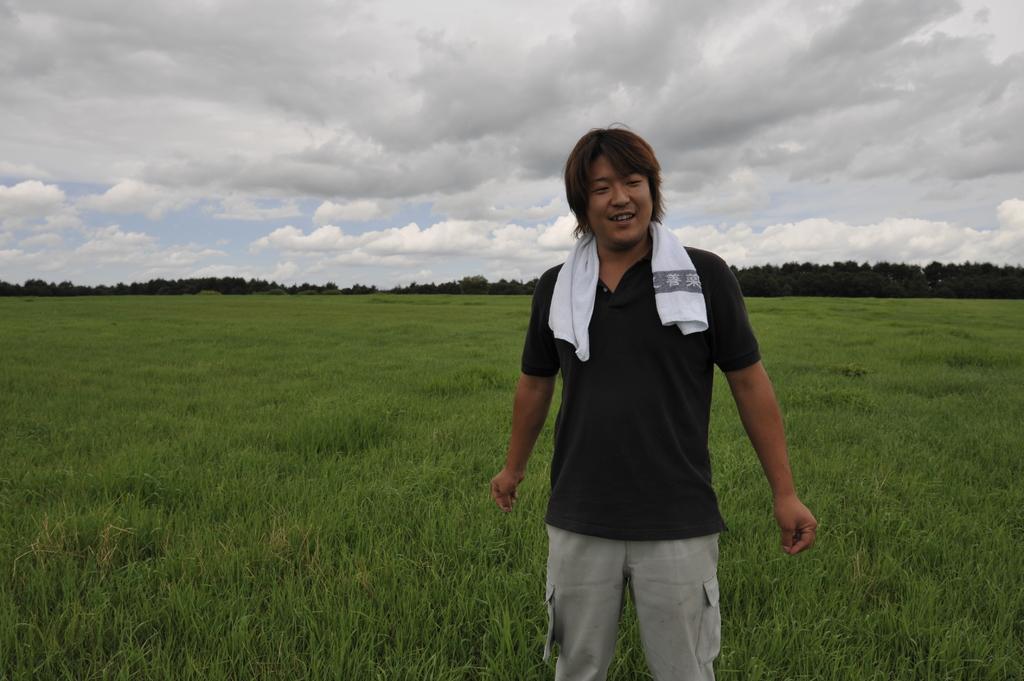In one or two sentences, can you explain what this image depicts? In this image we can see a person. In the background of the image there are grass, trees and other objects. At the top of the image there is the sky. 